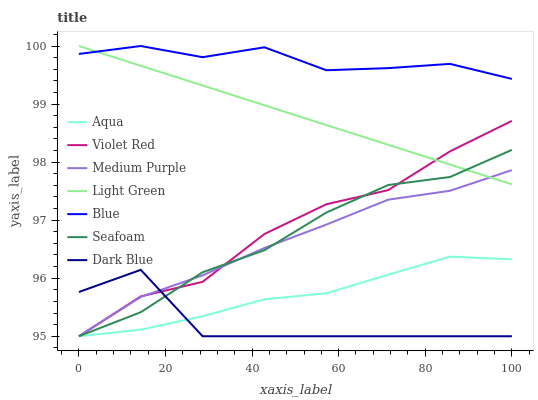Does Dark Blue have the minimum area under the curve?
Answer yes or no. Yes. Does Blue have the maximum area under the curve?
Answer yes or no. Yes. Does Violet Red have the minimum area under the curve?
Answer yes or no. No. Does Violet Red have the maximum area under the curve?
Answer yes or no. No. Is Light Green the smoothest?
Answer yes or no. Yes. Is Dark Blue the roughest?
Answer yes or no. Yes. Is Violet Red the smoothest?
Answer yes or no. No. Is Violet Red the roughest?
Answer yes or no. No. Does Violet Red have the lowest value?
Answer yes or no. Yes. Does Light Green have the lowest value?
Answer yes or no. No. Does Light Green have the highest value?
Answer yes or no. Yes. Does Violet Red have the highest value?
Answer yes or no. No. Is Seafoam less than Blue?
Answer yes or no. Yes. Is Blue greater than Dark Blue?
Answer yes or no. Yes. Does Medium Purple intersect Light Green?
Answer yes or no. Yes. Is Medium Purple less than Light Green?
Answer yes or no. No. Is Medium Purple greater than Light Green?
Answer yes or no. No. Does Seafoam intersect Blue?
Answer yes or no. No. 